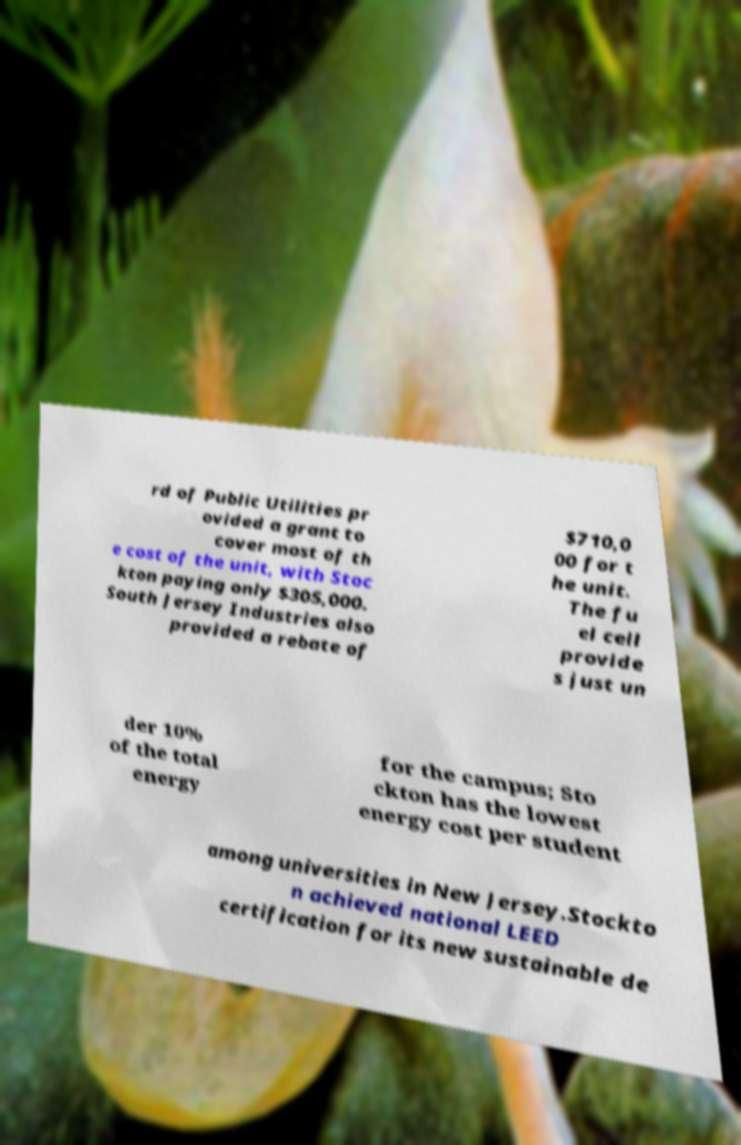Please identify and transcribe the text found in this image. rd of Public Utilities pr ovided a grant to cover most of th e cost of the unit, with Stoc kton paying only $305,000. South Jersey Industries also provided a rebate of $710,0 00 for t he unit. The fu el cell provide s just un der 10% of the total energy for the campus; Sto ckton has the lowest energy cost per student among universities in New Jersey.Stockto n achieved national LEED certification for its new sustainable de 